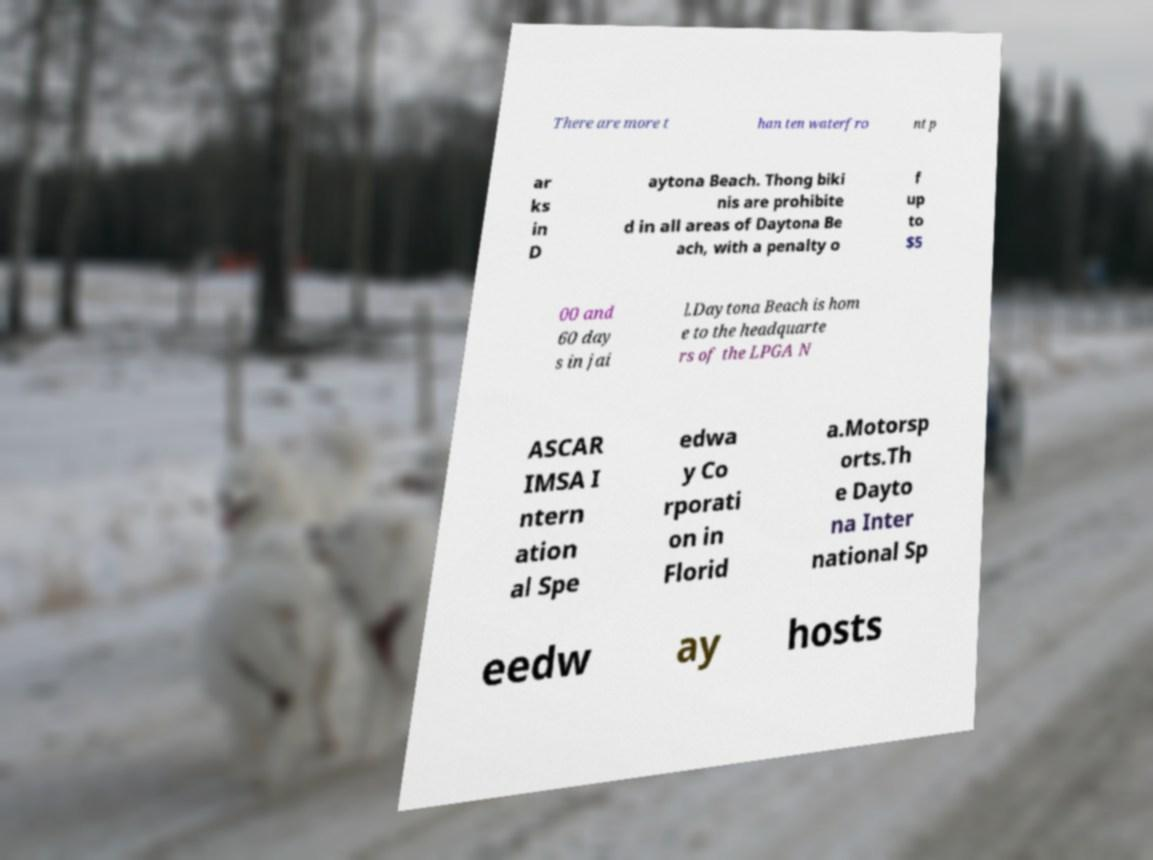I need the written content from this picture converted into text. Can you do that? There are more t han ten waterfro nt p ar ks in D aytona Beach. Thong biki nis are prohibite d in all areas of Daytona Be ach, with a penalty o f up to $5 00 and 60 day s in jai l.Daytona Beach is hom e to the headquarte rs of the LPGA N ASCAR IMSA I ntern ation al Spe edwa y Co rporati on in Florid a.Motorsp orts.Th e Dayto na Inter national Sp eedw ay hosts 